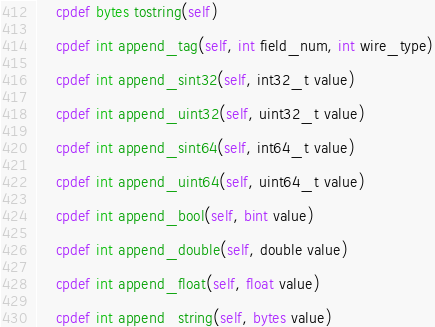Convert code to text. <code><loc_0><loc_0><loc_500><loc_500><_Cython_>    cpdef bytes tostring(self)

    cpdef int append_tag(self, int field_num, int wire_type)

    cpdef int append_sint32(self, int32_t value)

    cpdef int append_uint32(self, uint32_t value)

    cpdef int append_sint64(self, int64_t value)

    cpdef int append_uint64(self, uint64_t value)

    cpdef int append_bool(self, bint value)

    cpdef int append_double(self, double value)

    cpdef int append_float(self, float value)

    cpdef int append_string(self, bytes value)
</code> 